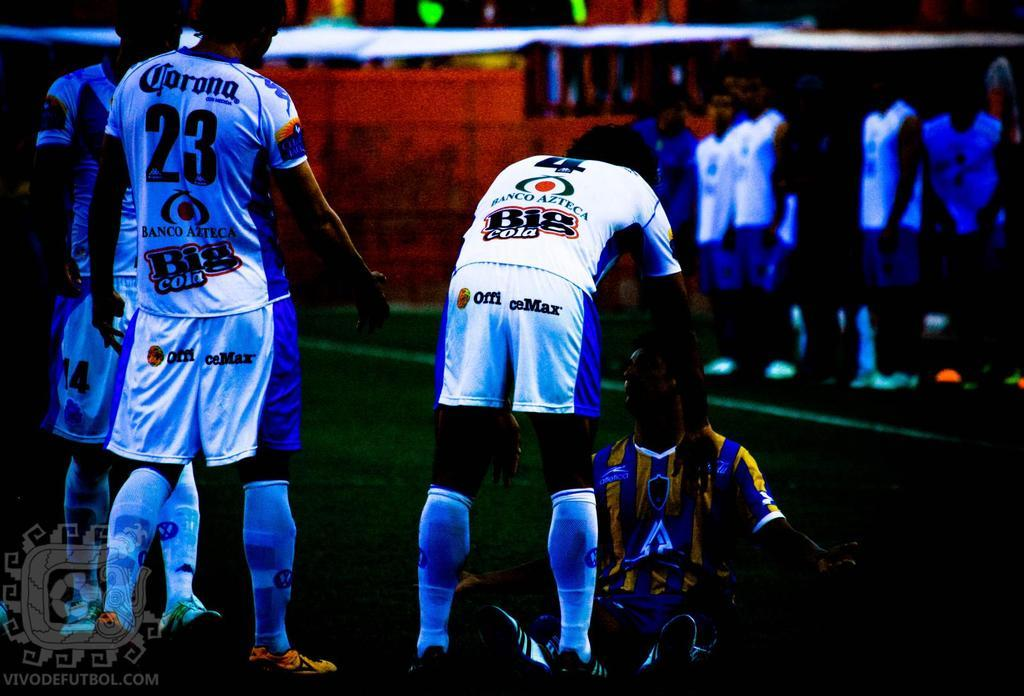<image>
Give a short and clear explanation of the subsequent image. a player has an Office Max logo on the back of their shorts 